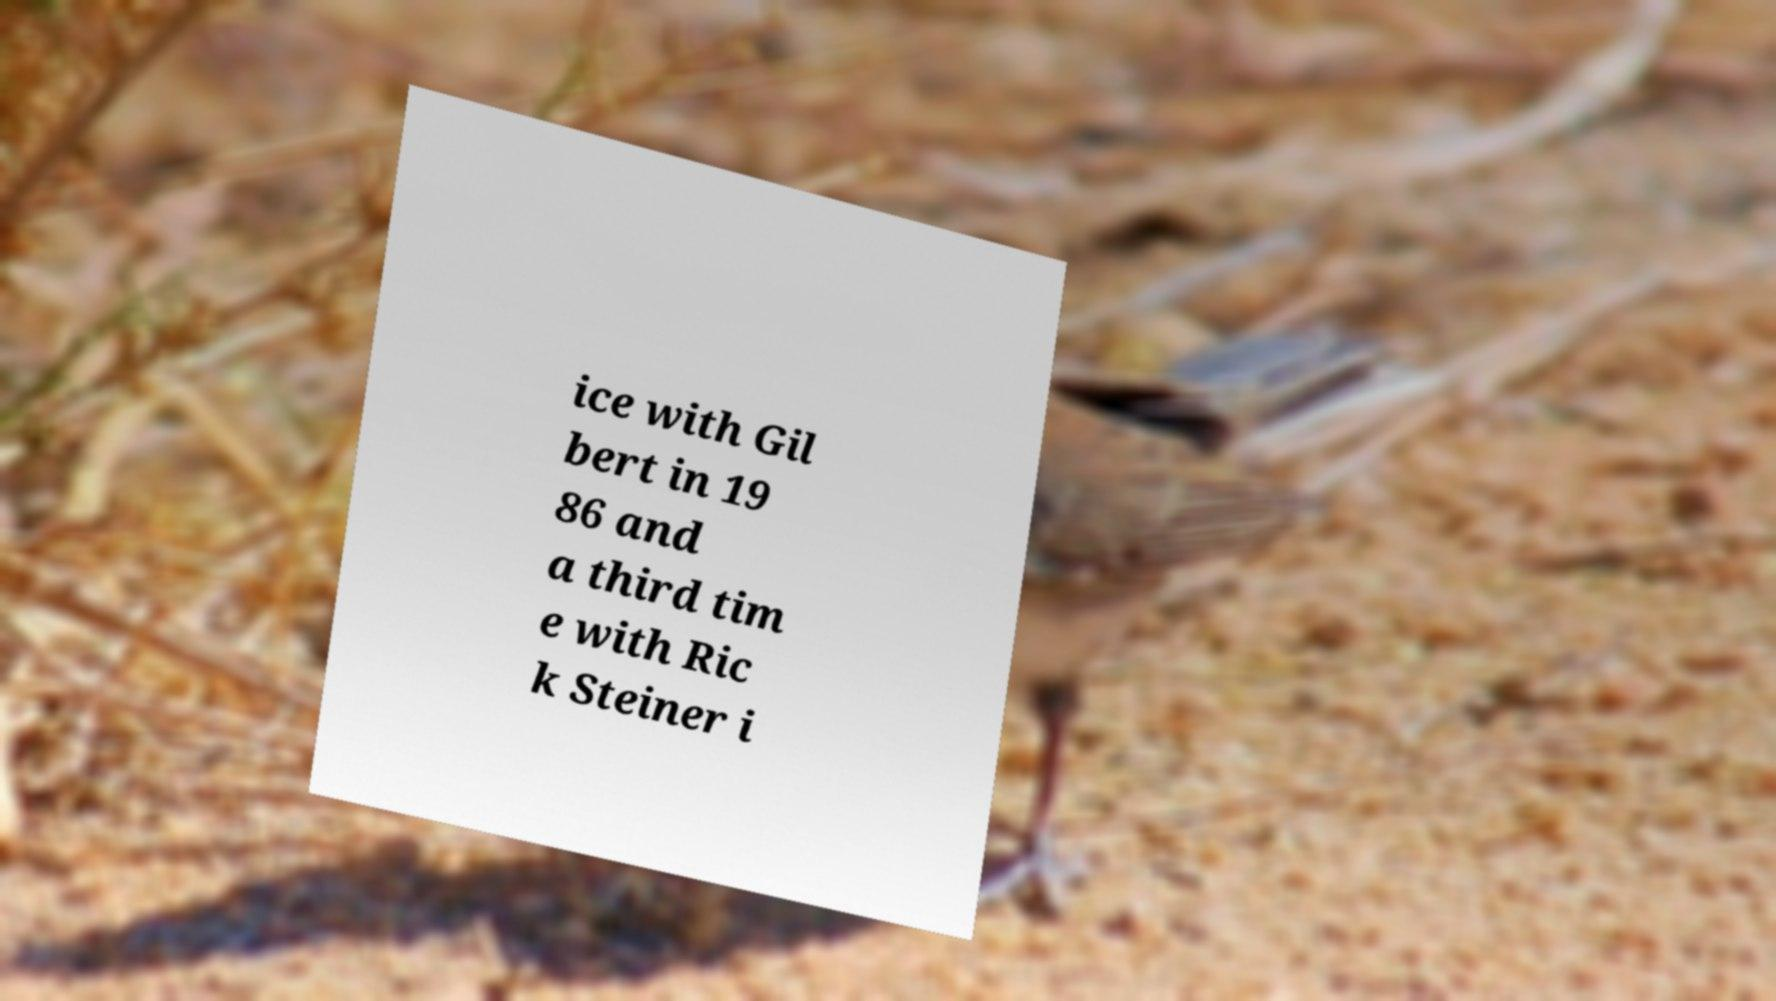There's text embedded in this image that I need extracted. Can you transcribe it verbatim? ice with Gil bert in 19 86 and a third tim e with Ric k Steiner i 